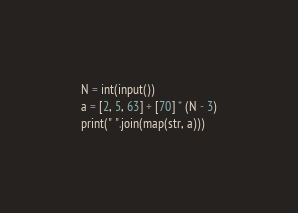<code> <loc_0><loc_0><loc_500><loc_500><_Python_>N = int(input())
a = [2, 5, 63] + [70] * (N - 3)
print(" ".join(map(str, a)))
</code> 